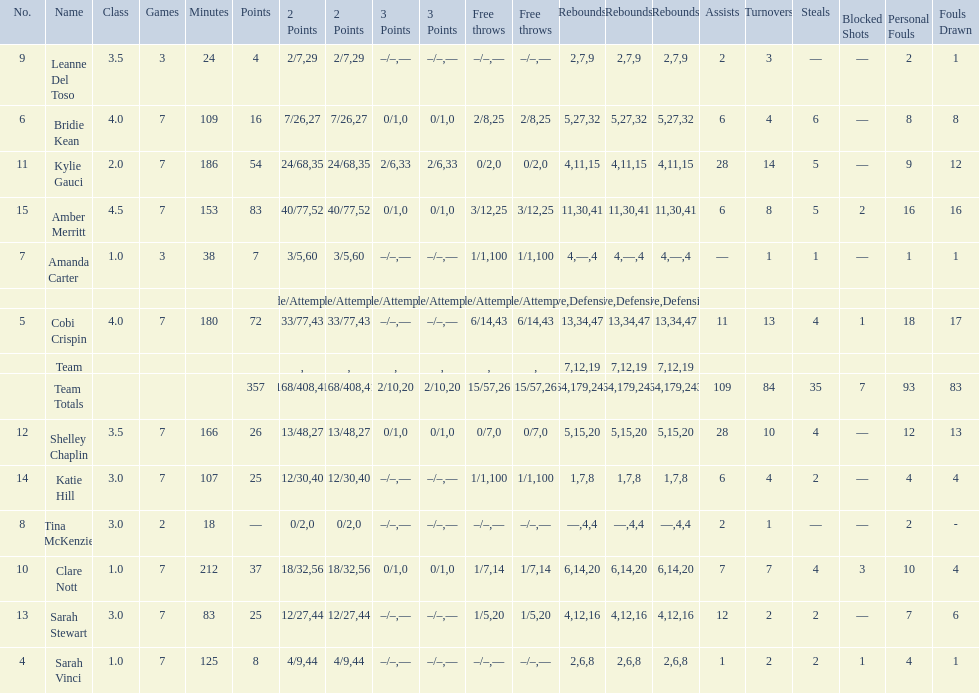Which player had the most total points? Amber Merritt. 